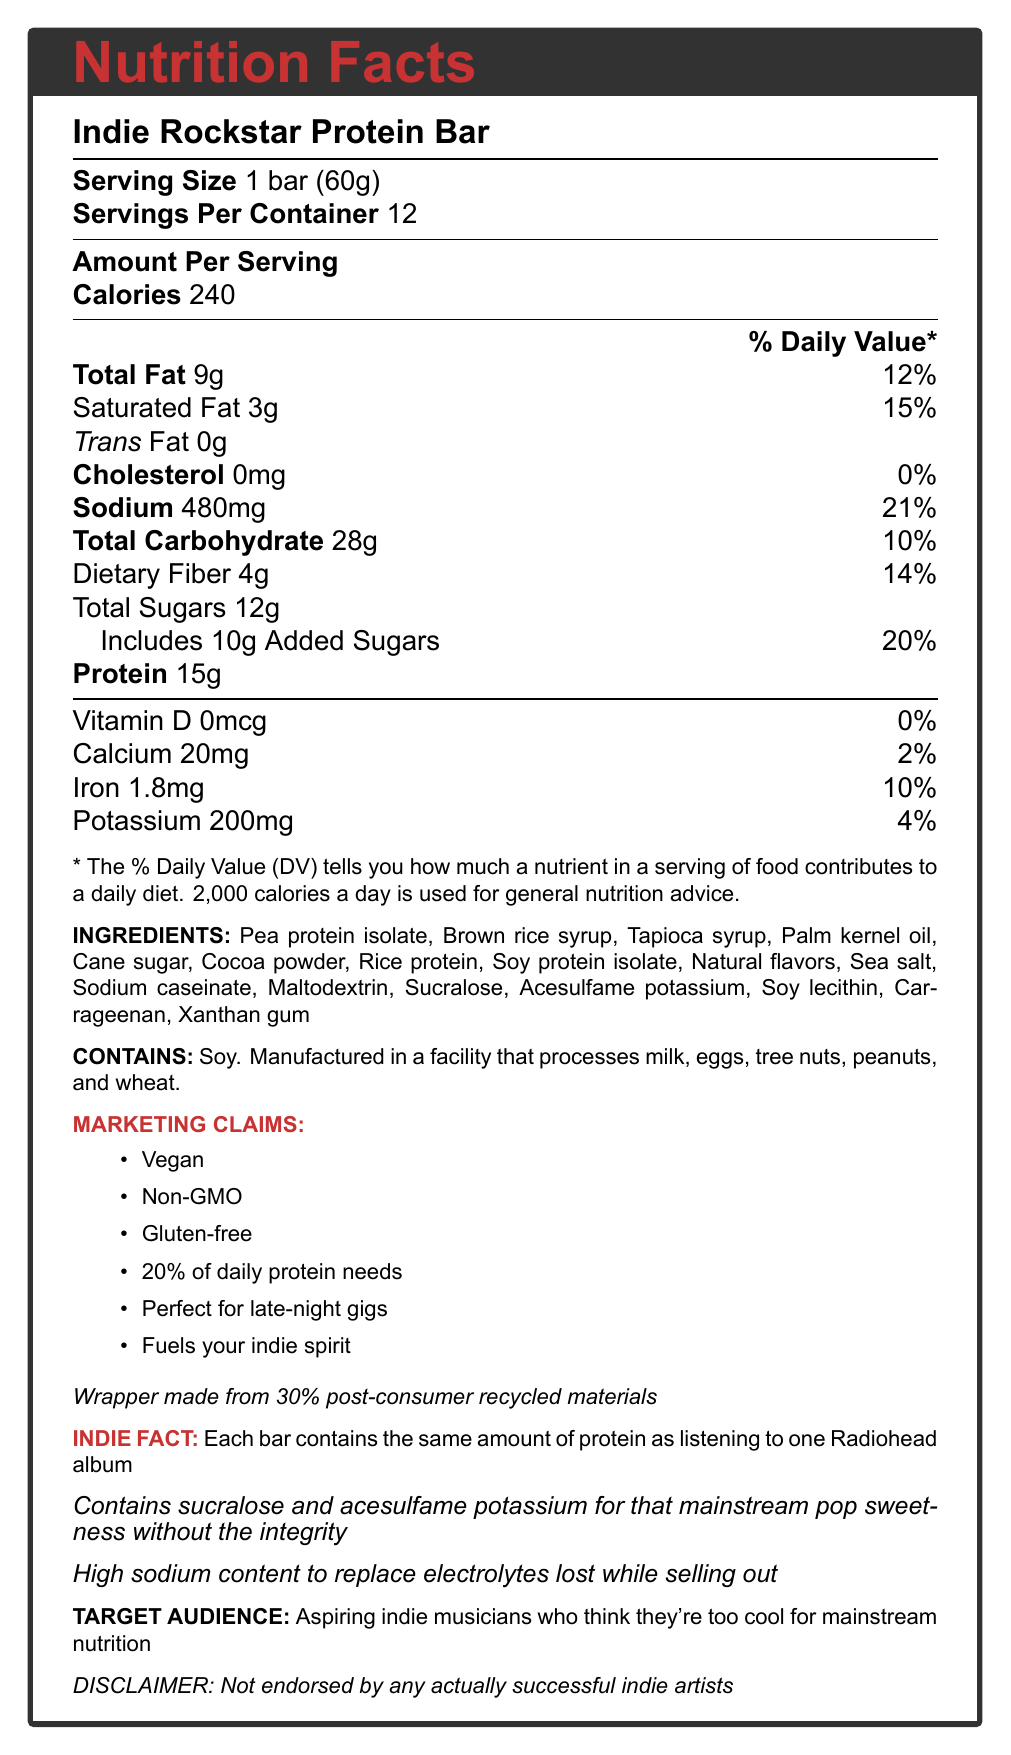what is the serving size of the Indie Rockstar Protein Bar? The serving size is clearly listed as "1 bar (60g)" in the document.
Answer: 1 bar (60g) how many servings are in one container of the Indie Rockstar Protein Bar? The document mentions there are "12" servings per container.
Answer: 12 what is the amount of sodium per serving, and its daily value percentage? The document indicates the sodium content per serving is "480mg" and its daily value is "21%".
Answer: 480mg, 21% which artificial sweeteners are listed in the ingredients? The ingredients list includes "Sucralose" and "Acesulfame potassium", both of which are artificial sweeteners.
Answer: Sucralose and Acesulfame potassium does the Indie Rockstar Protein Bar contain any cholesterol? The document states that cholesterol content is "0mg", indicating no cholesterol.
Answer: No which of these is NOT a claim made in the marketing section? A. Gluten-free B. Non-GMO C. Low-sodium D. Vegan The marketing claims include "Vegan", "Non-GMO", and "Gluten-free", but not "Low-sodium".
Answer: C which of the following is a potential allergen in the Indie Rockstar Protein Bar? A. Dairy B. Tree nuts C. Soy The allergen information in the document specifies "Contains soy".
Answer: C is this product endorsed by any successful indie artists? The document specifically states, "Not endorsed by any actually successful indie artists".
Answer: No describe the overall purpose and information content of the Indie Rockstar Protein Bar's nutrition label. The document provides a comprehensive summary of the Indie Rockstar Protein Bar, detailing its nutritional facts, ingredient list, marketing claims, and special notes appealing to indie musicians. It also touches on sustainability and disclaims any actual endorsement from successful indie musicians.
Answer: This document presents the nutritional details, ingredients, marketing claims, and other relevant information about the Indie Rockstar Protein Bar. It highlights key indices like calorie content, macronutrient distribution, ingredients (including artificial ones), allergen information, target audience, and sustainability aspects, all packaged with quirky marketing tailored for aspiring indie musicians. what percentage of the daily protein need is covered by one serving of the Indie Rockstar Protein Bar? The marketing claims specifically state "20% of daily protein needs".
Answer: 20% which ingredients contribute to the artificial ingredient content in the Indie Rockstar Protein Bar? The listed artificial ingredients include "Sucralose", "Acesulfame potassium", and "Maltodextrin".
Answer: Sucralose, Acesulfame potassium, Maltodextrin what is the wrapper of the Indie Rockstar Protein Bar made from? A. 100% new materials B. 30% post-consumer recycled materials C. Non-recyclable materials The document mentions, "Wrapper made from 30% post-consumer recycled materials".
Answer: B what amount of calcium does one bar provide? The document indicates the calcium content is "20mg" per serving.
Answer: 20mg how much protein does one Indie Rockstar Protein Bar contain? According to the document, each protein bar contains "15g" of protein.
Answer: 15g does the Indie Rockstar Protein Bar contribute to iron intake? The document shows that each serving contains "1.8mg" of iron, contributing to 10% of the daily value.
Answer: Yes does the document mention the calorie count for the bar? The document states that each bar contains 240 calories.
Answer: Yes are there any successful indie artists endorsing this product? The document states, "Not endorsed by any actually successful indie artists", but it does not provide information about endorsements from non-successful or other types of artists.
Answer: Cannot be determined 